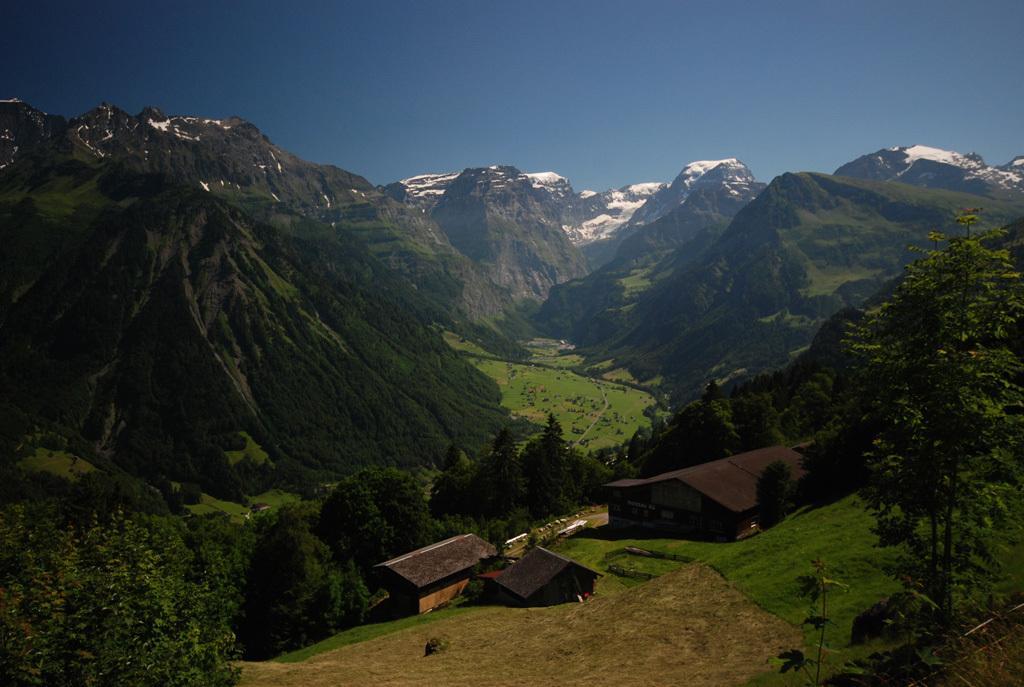Could you give a brief overview of what you see in this image? In this image I can see the houses. To the side of the houses I can see many trees. In the background I can see the mountains and the blue sky. 